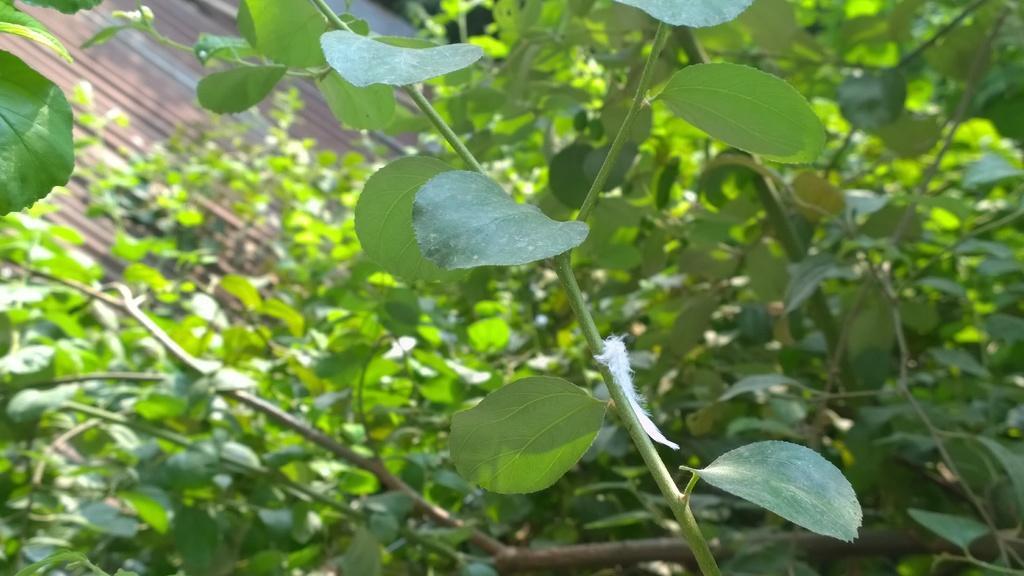Please provide a concise description of this image. In this picture we can see trees and in the background we can see an object. 